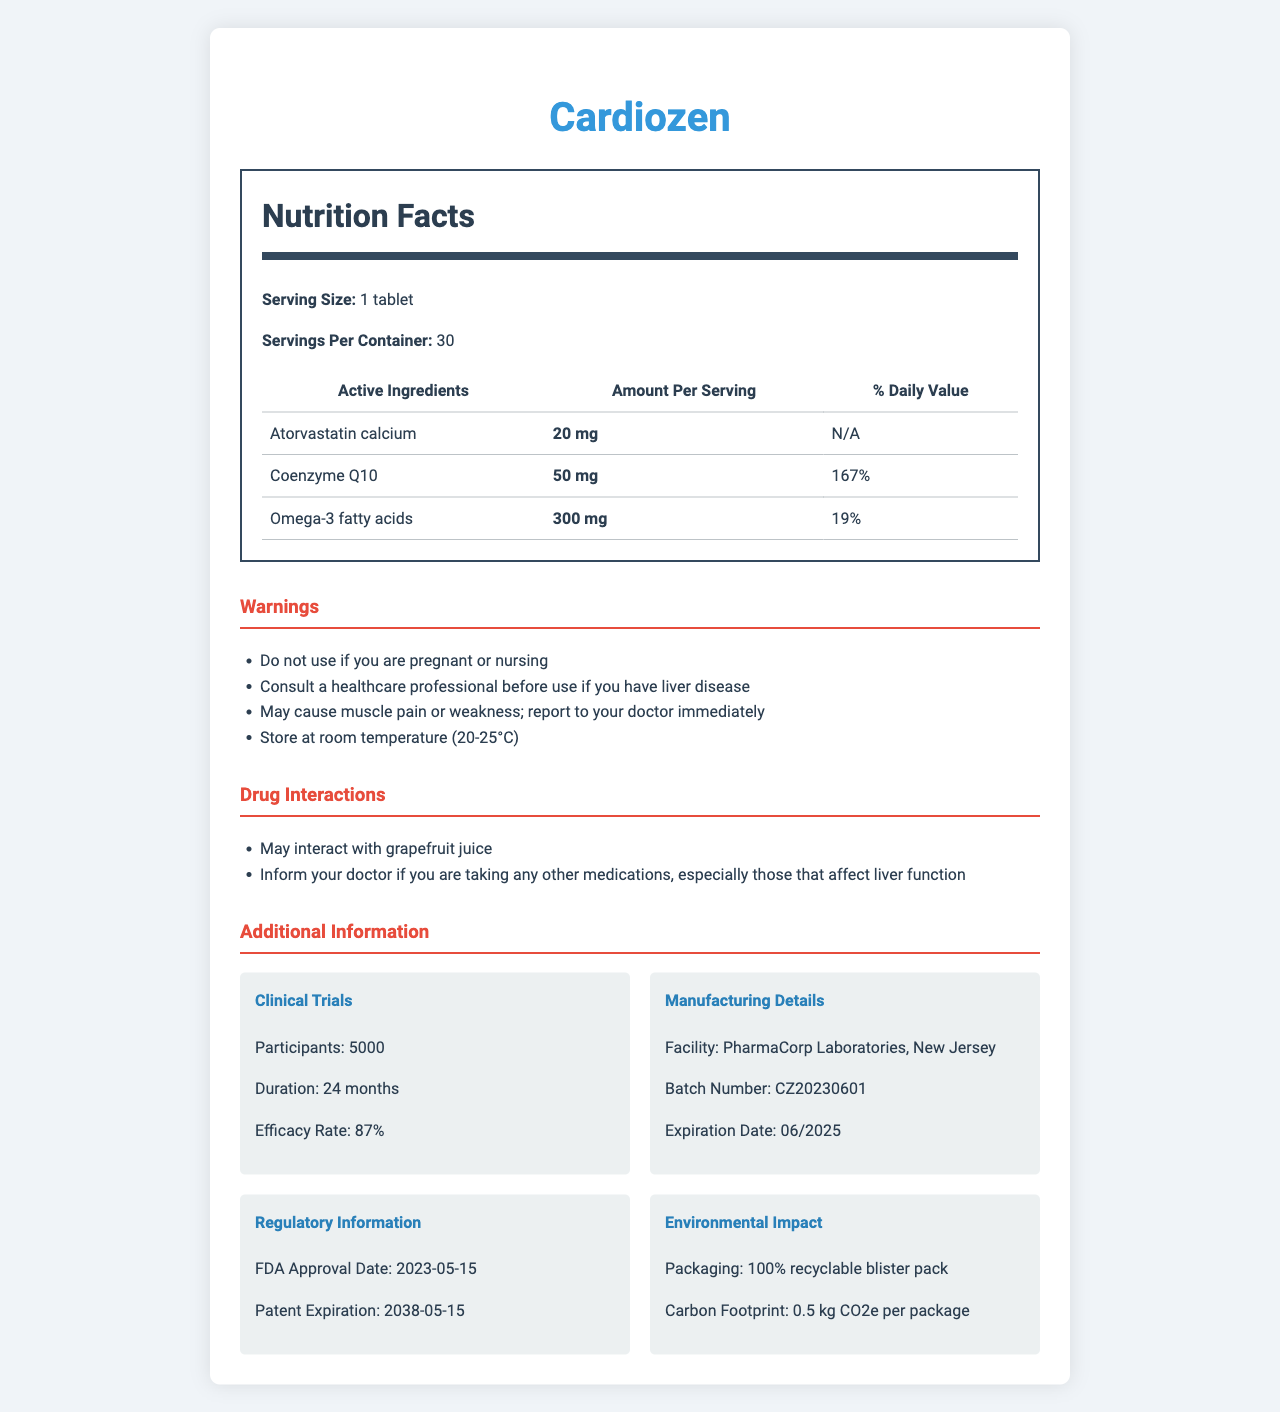what is the serving size of Cardiozen? The document specifies that the serving size of Cardiozen is 1 tablet.
Answer: 1 tablet how many servings are there per container? According to the document, there are 30 servings per container of Cardiozen.
Answer: 30 what is the amount of Coenzyme Q10 per serving? The document lists Coenzyme Q10 as an active ingredient and states that each serving contains 50 mg.
Answer: 50 mg what are the inactive ingredients in Cardiozen? The inactive ingredients are listed under that section in the document.
Answer: Microcrystalline cellulose, Lactose monohydrate, Croscarmellose sodium, Magnesium stearate, Hydroxypropyl methylcellulose, Titanium dioxide, Polyethylene glycol what is the duration of the clinical trials for Cardiozen? The document states that the clinical trials for Cardiozen lasted for 24 months.
Answer: 24 months how much Omega-3 fatty acids are included per serving? A. 50 mg B. 150 mg C. 300 mg The document specifies that each serving of Cardiozen contains 300 mg of Omega-3 fatty acids.
Answer: C which of the following is a warning associated with Cardiozen? A. Do not use if you are pregnant or nursing B. Store in the freezer C. Consult a dentist before use The document includes "Do not use if you are pregnant or nursing" as one of the warnings.
Answer: A is it safe to store Cardiozen at room temperature? The document advises storing Cardiozen at room temperature (20-25°C).
Answer: Yes summarize the document. The document includes a detailed breakdown of various aspects pertaining to Cardiozen, making it a valuable resource for understanding the product.
Answer: The document provides comprehensive information about Cardiozen, a pharmaceutical drug. It details the serving size, servings per container, and active and inactive ingredients. It also includes warnings, drug interactions, clinical trial data, manufacturing details, regulatory information, and the environmental impact of the product. Additionally, it mentions alternative testing methods used in its development. how many participants were involved in the clinical trials? The question is meant to provide an example of an unanswerable question. The actual document states that 5000 participants were involved, but this question prompts to check if there is confusion due to a lack of context in the question itself.
Answer: Cannot be determined what is the efficacy rate obtained from the clinical trials? The document notes that the clinical trials for Cardiozen reported an efficacy rate of 87%.
Answer: 87% which ingredient does not have a daily value listed? The daily value is listed as "N/A" or not applicable for Atorvastatin calcium in the document.
Answer: Atorvastatin calcium what should you do if you experience muscle pain or weakness while taking Cardiozen? The warnings section in the document advises to report to your doctor immediately if you experience muscle pain or weakness.
Answer: Report to your doctor immediately 